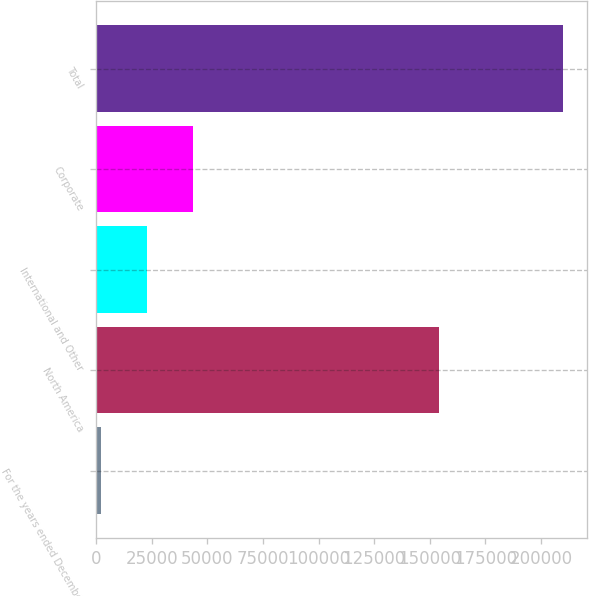Convert chart. <chart><loc_0><loc_0><loc_500><loc_500><bar_chart><fcel>For the years ended December<fcel>North America<fcel>International and Other<fcel>Corporate<fcel>Total<nl><fcel>2012<fcel>154348<fcel>22814.5<fcel>43617<fcel>210037<nl></chart> 